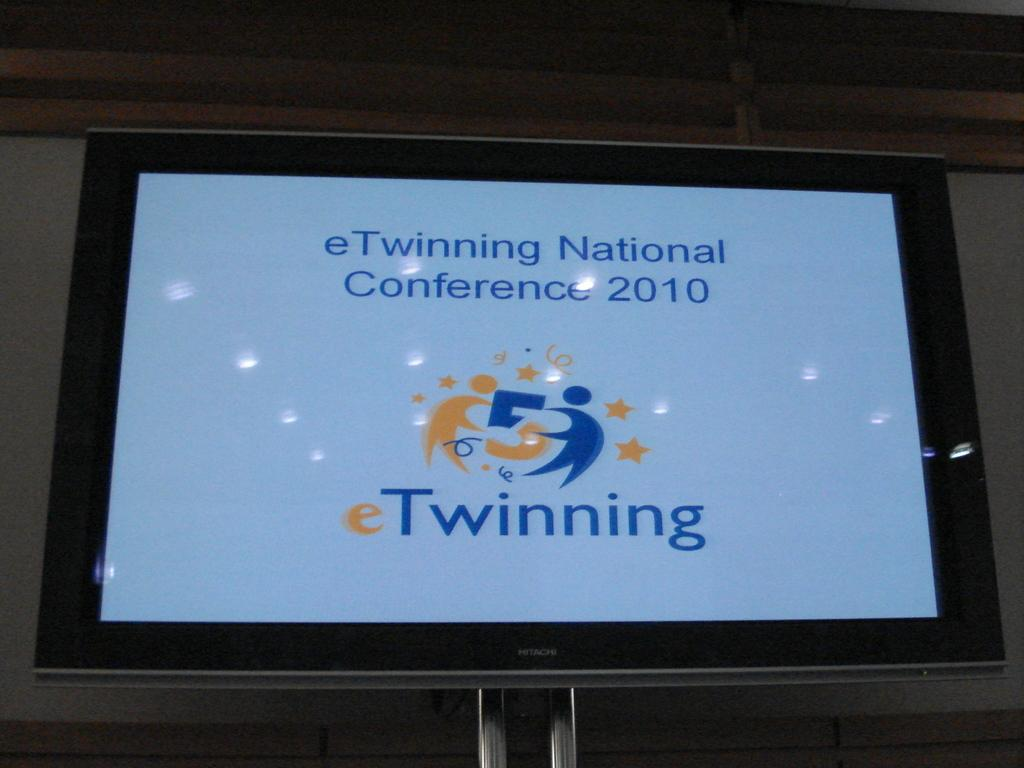<image>
Summarize the visual content of the image. A white background with the words eTwinning National Conference 2010. 